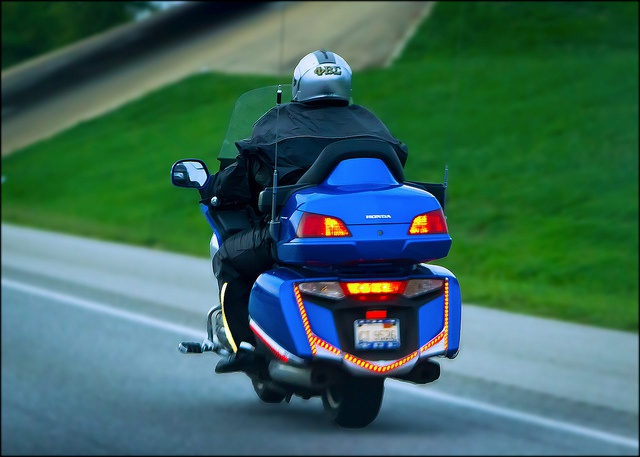Describe the objects in this image and their specific colors. I can see motorcycle in black, blue, navy, and darkblue tones and people in black, blue, darkblue, and lavender tones in this image. 